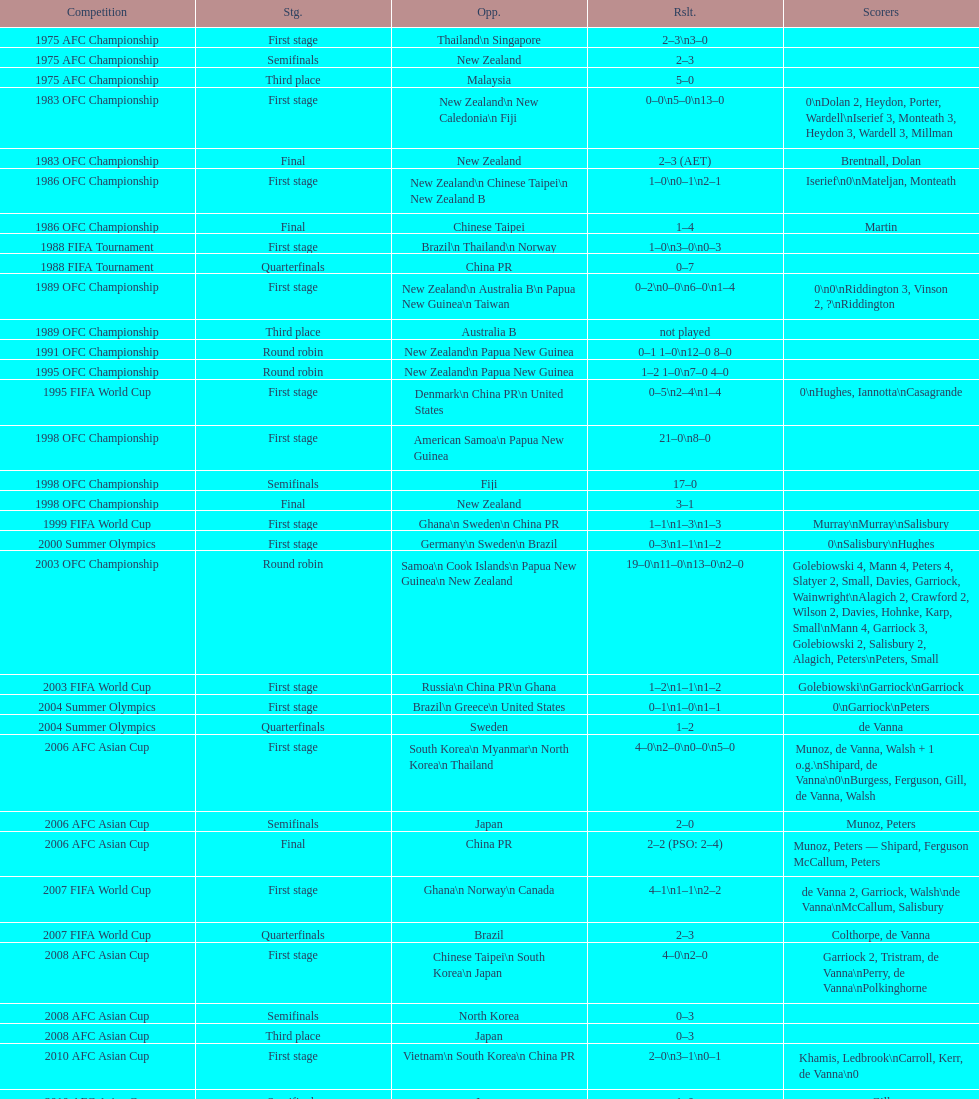Can you parse all the data within this table? {'header': ['Competition', 'Stg.', 'Opp.', 'Rslt.', 'Scorers'], 'rows': [['1975 AFC Championship', 'First stage', 'Thailand\\n\xa0Singapore', '2–3\\n3–0', ''], ['1975 AFC Championship', 'Semifinals', 'New Zealand', '2–3', ''], ['1975 AFC Championship', 'Third place', 'Malaysia', '5–0', ''], ['1983 OFC Championship', 'First stage', 'New Zealand\\n\xa0New Caledonia\\n\xa0Fiji', '0–0\\n5–0\\n13–0', '0\\nDolan 2, Heydon, Porter, Wardell\\nIserief 3, Monteath 3, Heydon 3, Wardell 3, Millman'], ['1983 OFC Championship', 'Final', 'New Zealand', '2–3 (AET)', 'Brentnall, Dolan'], ['1986 OFC Championship', 'First stage', 'New Zealand\\n\xa0Chinese Taipei\\n New Zealand B', '1–0\\n0–1\\n2–1', 'Iserief\\n0\\nMateljan, Monteath'], ['1986 OFC Championship', 'Final', 'Chinese Taipei', '1–4', 'Martin'], ['1988 FIFA Tournament', 'First stage', 'Brazil\\n\xa0Thailand\\n\xa0Norway', '1–0\\n3–0\\n0–3', ''], ['1988 FIFA Tournament', 'Quarterfinals', 'China PR', '0–7', ''], ['1989 OFC Championship', 'First stage', 'New Zealand\\n Australia B\\n\xa0Papua New Guinea\\n\xa0Taiwan', '0–2\\n0–0\\n6–0\\n1–4', '0\\n0\\nRiddington 3, Vinson 2,\xa0?\\nRiddington'], ['1989 OFC Championship', 'Third place', 'Australia B', 'not played', ''], ['1991 OFC Championship', 'Round robin', 'New Zealand\\n\xa0Papua New Guinea', '0–1 1–0\\n12–0 8–0', ''], ['1995 OFC Championship', 'Round robin', 'New Zealand\\n\xa0Papua New Guinea', '1–2 1–0\\n7–0 4–0', ''], ['1995 FIFA World Cup', 'First stage', 'Denmark\\n\xa0China PR\\n\xa0United States', '0–5\\n2–4\\n1–4', '0\\nHughes, Iannotta\\nCasagrande'], ['1998 OFC Championship', 'First stage', 'American Samoa\\n\xa0Papua New Guinea', '21–0\\n8–0', ''], ['1998 OFC Championship', 'Semifinals', 'Fiji', '17–0', ''], ['1998 OFC Championship', 'Final', 'New Zealand', '3–1', ''], ['1999 FIFA World Cup', 'First stage', 'Ghana\\n\xa0Sweden\\n\xa0China PR', '1–1\\n1–3\\n1–3', 'Murray\\nMurray\\nSalisbury'], ['2000 Summer Olympics', 'First stage', 'Germany\\n\xa0Sweden\\n\xa0Brazil', '0–3\\n1–1\\n1–2', '0\\nSalisbury\\nHughes'], ['2003 OFC Championship', 'Round robin', 'Samoa\\n\xa0Cook Islands\\n\xa0Papua New Guinea\\n\xa0New Zealand', '19–0\\n11–0\\n13–0\\n2–0', 'Golebiowski 4, Mann 4, Peters 4, Slatyer 2, Small, Davies, Garriock, Wainwright\\nAlagich 2, Crawford 2, Wilson 2, Davies, Hohnke, Karp, Small\\nMann 4, Garriock 3, Golebiowski 2, Salisbury 2, Alagich, Peters\\nPeters, Small'], ['2003 FIFA World Cup', 'First stage', 'Russia\\n\xa0China PR\\n\xa0Ghana', '1–2\\n1–1\\n1–2', 'Golebiowski\\nGarriock\\nGarriock'], ['2004 Summer Olympics', 'First stage', 'Brazil\\n\xa0Greece\\n\xa0United States', '0–1\\n1–0\\n1–1', '0\\nGarriock\\nPeters'], ['2004 Summer Olympics', 'Quarterfinals', 'Sweden', '1–2', 'de Vanna'], ['2006 AFC Asian Cup', 'First stage', 'South Korea\\n\xa0Myanmar\\n\xa0North Korea\\n\xa0Thailand', '4–0\\n2–0\\n0–0\\n5–0', 'Munoz, de Vanna, Walsh + 1 o.g.\\nShipard, de Vanna\\n0\\nBurgess, Ferguson, Gill, de Vanna, Walsh'], ['2006 AFC Asian Cup', 'Semifinals', 'Japan', '2–0', 'Munoz, Peters'], ['2006 AFC Asian Cup', 'Final', 'China PR', '2–2 (PSO: 2–4)', 'Munoz, Peters — Shipard, Ferguson McCallum, Peters'], ['2007 FIFA World Cup', 'First stage', 'Ghana\\n\xa0Norway\\n\xa0Canada', '4–1\\n1–1\\n2–2', 'de Vanna 2, Garriock, Walsh\\nde Vanna\\nMcCallum, Salisbury'], ['2007 FIFA World Cup', 'Quarterfinals', 'Brazil', '2–3', 'Colthorpe, de Vanna'], ['2008 AFC Asian Cup', 'First stage', 'Chinese Taipei\\n\xa0South Korea\\n\xa0Japan', '4–0\\n2–0', 'Garriock 2, Tristram, de Vanna\\nPerry, de Vanna\\nPolkinghorne'], ['2008 AFC Asian Cup', 'Semifinals', 'North Korea', '0–3', ''], ['2008 AFC Asian Cup', 'Third place', 'Japan', '0–3', ''], ['2010 AFC Asian Cup', 'First stage', 'Vietnam\\n\xa0South Korea\\n\xa0China PR', '2–0\\n3–1\\n0–1', 'Khamis, Ledbrook\\nCarroll, Kerr, de Vanna\\n0'], ['2010 AFC Asian Cup', 'Semifinals', 'Japan', '1–0', 'Gill'], ['2010 AFC Asian Cup', 'Final', 'North Korea', '1–1 (PSO: 5–4)', 'Kerr — PSO: Shipard, Ledbrook, Gill, Garriock, Simon'], ['2011 FIFA World Cup', 'First stage', 'Brazil\\n\xa0Equatorial Guinea\\n\xa0Norway', '0–1\\n3–2\\n2–1', '0\\nvan Egmond, Khamis, de Vanna\\nSimon 2'], ['2011 FIFA World Cup', 'Quarterfinals', 'Sweden', '1–3', 'Perry'], ['2012 Summer Olympics\\nAFC qualification', 'Final round', 'North Korea\\n\xa0Thailand\\n\xa0Japan\\n\xa0China PR\\n\xa0South Korea', '0–1\\n5–1\\n0–1\\n1–0\\n2–1', '0\\nHeyman 2, Butt, van Egmond, Simon\\n0\\nvan Egmond\\nButt, de Vanna'], ['2014 AFC Asian Cup', 'First stage', 'Japan\\n\xa0Jordan\\n\xa0Vietnam', 'TBD\\nTBD\\nTBD', '']]} What is the difference in the number of goals scored in the 1999 fifa world cup and the 2000 summer olympics? 2. 